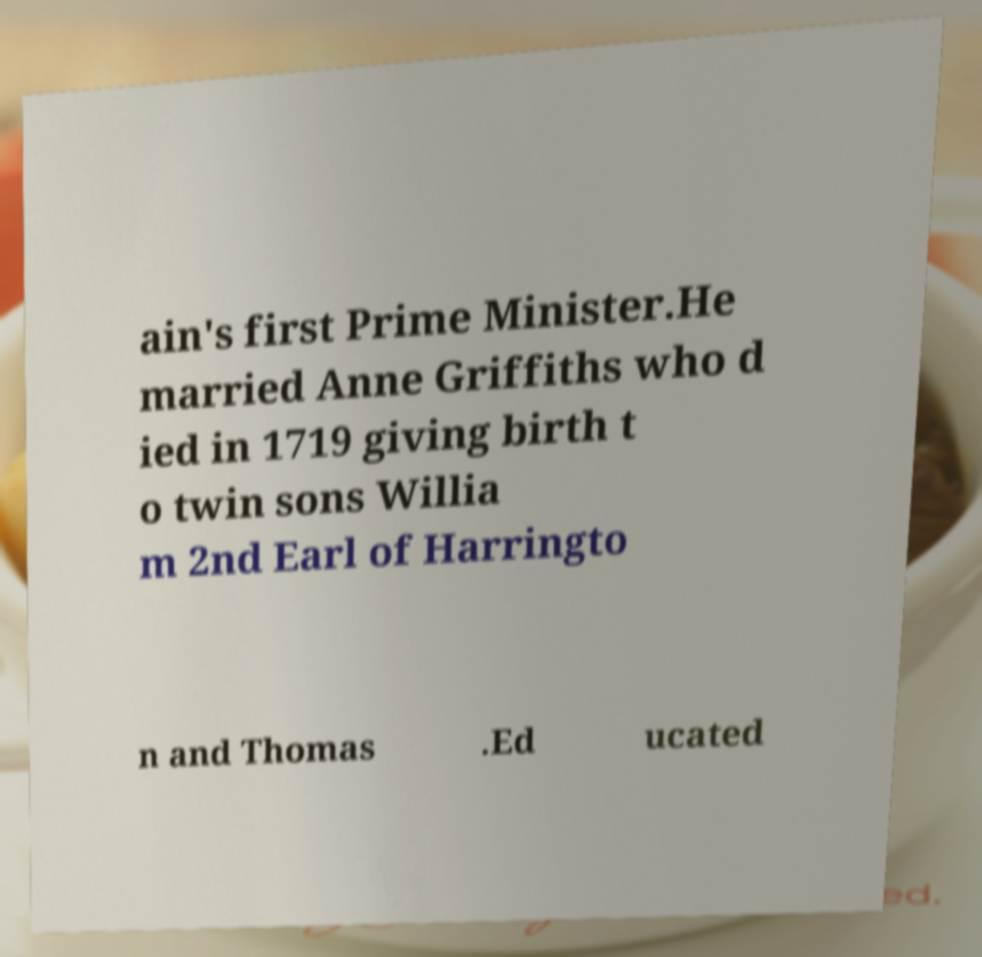There's text embedded in this image that I need extracted. Can you transcribe it verbatim? ain's first Prime Minister.He married Anne Griffiths who d ied in 1719 giving birth t o twin sons Willia m 2nd Earl of Harringto n and Thomas .Ed ucated 